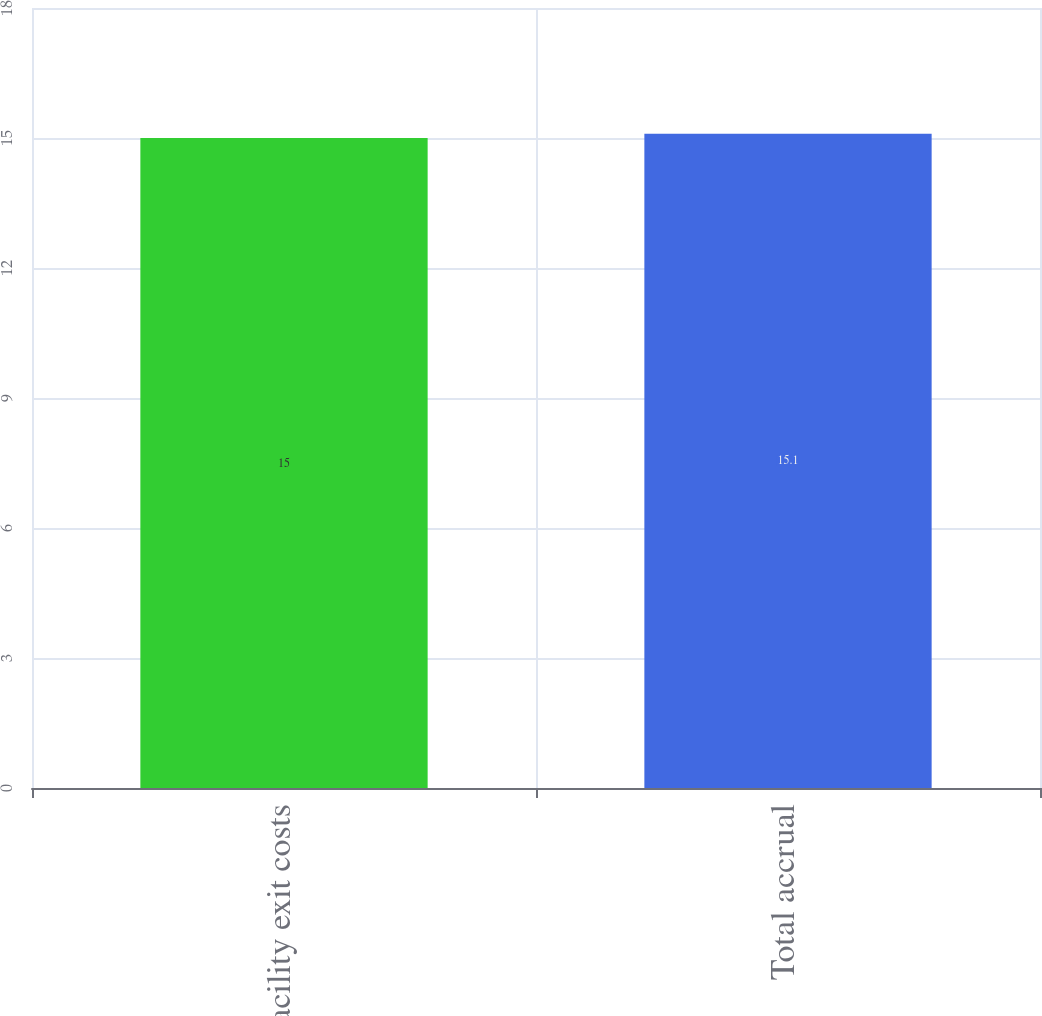Convert chart. <chart><loc_0><loc_0><loc_500><loc_500><bar_chart><fcel>Facility exit costs<fcel>Total accrual<nl><fcel>15<fcel>15.1<nl></chart> 